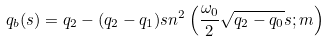<formula> <loc_0><loc_0><loc_500><loc_500>q _ { b } ( s ) = q _ { 2 } - ( q _ { 2 } - q _ { 1 } ) s n ^ { 2 } \left ( \frac { \omega _ { 0 } } { 2 } \sqrt { q _ { 2 } - q _ { 0 } } s ; m \right )</formula> 